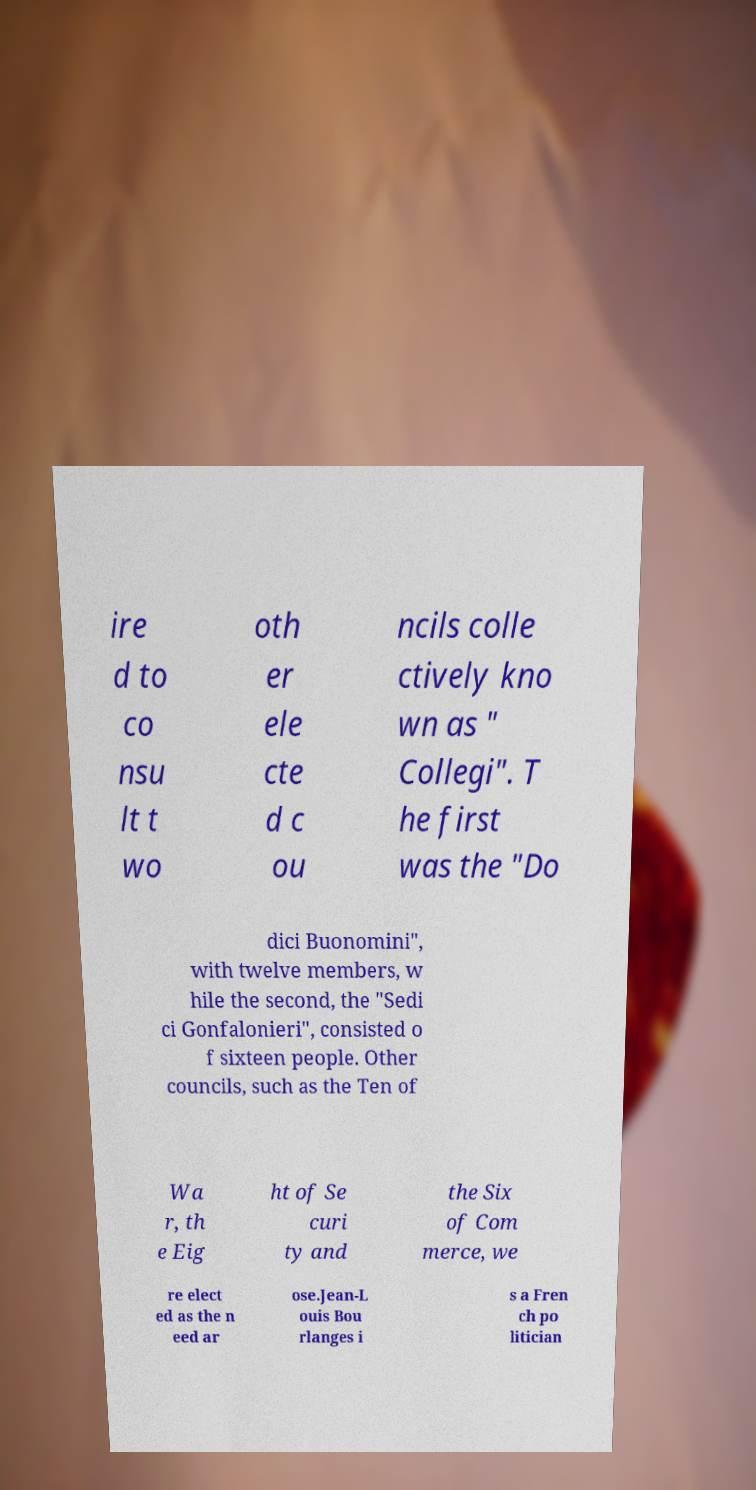There's text embedded in this image that I need extracted. Can you transcribe it verbatim? ire d to co nsu lt t wo oth er ele cte d c ou ncils colle ctively kno wn as " Collegi". T he first was the "Do dici Buonomini", with twelve members, w hile the second, the "Sedi ci Gonfalonieri", consisted o f sixteen people. Other councils, such as the Ten of Wa r, th e Eig ht of Se curi ty and the Six of Com merce, we re elect ed as the n eed ar ose.Jean-L ouis Bou rlanges i s a Fren ch po litician 